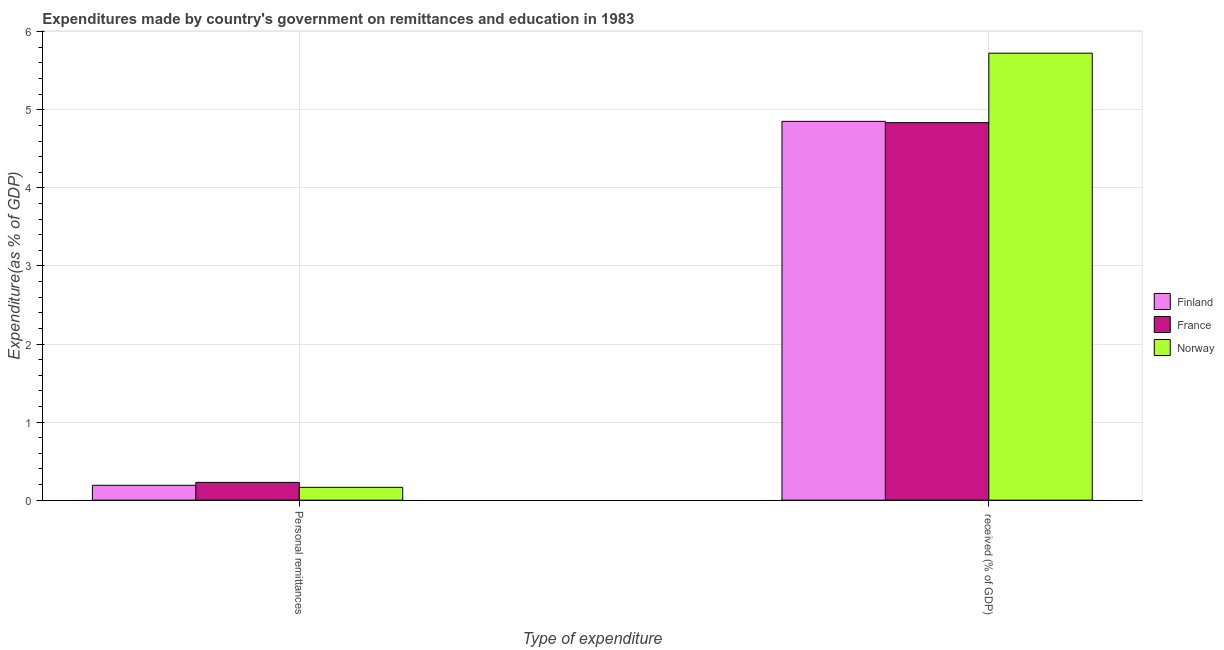How many different coloured bars are there?
Give a very brief answer. 3. Are the number of bars per tick equal to the number of legend labels?
Your response must be concise. Yes. How many bars are there on the 1st tick from the left?
Ensure brevity in your answer.  3. What is the label of the 1st group of bars from the left?
Your response must be concise. Personal remittances. What is the expenditure in personal remittances in Norway?
Your response must be concise. 0.16. Across all countries, what is the maximum expenditure in education?
Offer a terse response. 5.73. Across all countries, what is the minimum expenditure in education?
Your answer should be very brief. 4.84. In which country was the expenditure in education maximum?
Offer a very short reply. Norway. What is the total expenditure in education in the graph?
Offer a very short reply. 15.41. What is the difference between the expenditure in education in France and that in Norway?
Offer a very short reply. -0.89. What is the difference between the expenditure in education in France and the expenditure in personal remittances in Norway?
Your response must be concise. 4.67. What is the average expenditure in personal remittances per country?
Offer a terse response. 0.19. What is the difference between the expenditure in education and expenditure in personal remittances in Norway?
Provide a short and direct response. 5.56. In how many countries, is the expenditure in education greater than 5.4 %?
Offer a terse response. 1. What is the ratio of the expenditure in education in Finland to that in Norway?
Your answer should be very brief. 0.85. Is the expenditure in personal remittances in Finland less than that in Norway?
Offer a very short reply. No. In how many countries, is the expenditure in education greater than the average expenditure in education taken over all countries?
Give a very brief answer. 1. What does the 1st bar from the left in  received (% of GDP) represents?
Make the answer very short. Finland. What does the 2nd bar from the right in Personal remittances represents?
Give a very brief answer. France. Are all the bars in the graph horizontal?
Keep it short and to the point. No. What is the difference between two consecutive major ticks on the Y-axis?
Offer a very short reply. 1. Are the values on the major ticks of Y-axis written in scientific E-notation?
Ensure brevity in your answer.  No. Does the graph contain any zero values?
Offer a terse response. No. How are the legend labels stacked?
Your answer should be compact. Vertical. What is the title of the graph?
Offer a very short reply. Expenditures made by country's government on remittances and education in 1983. Does "Latvia" appear as one of the legend labels in the graph?
Offer a terse response. No. What is the label or title of the X-axis?
Give a very brief answer. Type of expenditure. What is the label or title of the Y-axis?
Provide a succinct answer. Expenditure(as % of GDP). What is the Expenditure(as % of GDP) of Finland in Personal remittances?
Make the answer very short. 0.19. What is the Expenditure(as % of GDP) of France in Personal remittances?
Provide a short and direct response. 0.23. What is the Expenditure(as % of GDP) of Norway in Personal remittances?
Make the answer very short. 0.16. What is the Expenditure(as % of GDP) of Finland in  received (% of GDP)?
Your response must be concise. 4.85. What is the Expenditure(as % of GDP) of France in  received (% of GDP)?
Ensure brevity in your answer.  4.84. What is the Expenditure(as % of GDP) of Norway in  received (% of GDP)?
Ensure brevity in your answer.  5.73. Across all Type of expenditure, what is the maximum Expenditure(as % of GDP) in Finland?
Ensure brevity in your answer.  4.85. Across all Type of expenditure, what is the maximum Expenditure(as % of GDP) of France?
Give a very brief answer. 4.84. Across all Type of expenditure, what is the maximum Expenditure(as % of GDP) of Norway?
Provide a succinct answer. 5.73. Across all Type of expenditure, what is the minimum Expenditure(as % of GDP) in Finland?
Offer a very short reply. 0.19. Across all Type of expenditure, what is the minimum Expenditure(as % of GDP) of France?
Your answer should be very brief. 0.23. Across all Type of expenditure, what is the minimum Expenditure(as % of GDP) in Norway?
Your answer should be compact. 0.16. What is the total Expenditure(as % of GDP) in Finland in the graph?
Provide a short and direct response. 5.04. What is the total Expenditure(as % of GDP) of France in the graph?
Ensure brevity in your answer.  5.06. What is the total Expenditure(as % of GDP) in Norway in the graph?
Your answer should be compact. 5.89. What is the difference between the Expenditure(as % of GDP) of Finland in Personal remittances and that in  received (% of GDP)?
Your answer should be very brief. -4.66. What is the difference between the Expenditure(as % of GDP) in France in Personal remittances and that in  received (% of GDP)?
Provide a succinct answer. -4.61. What is the difference between the Expenditure(as % of GDP) in Norway in Personal remittances and that in  received (% of GDP)?
Offer a very short reply. -5.56. What is the difference between the Expenditure(as % of GDP) in Finland in Personal remittances and the Expenditure(as % of GDP) in France in  received (% of GDP)?
Make the answer very short. -4.64. What is the difference between the Expenditure(as % of GDP) of Finland in Personal remittances and the Expenditure(as % of GDP) of Norway in  received (% of GDP)?
Offer a terse response. -5.53. What is the difference between the Expenditure(as % of GDP) of France in Personal remittances and the Expenditure(as % of GDP) of Norway in  received (% of GDP)?
Offer a terse response. -5.5. What is the average Expenditure(as % of GDP) in Finland per Type of expenditure?
Your answer should be very brief. 2.52. What is the average Expenditure(as % of GDP) in France per Type of expenditure?
Give a very brief answer. 2.53. What is the average Expenditure(as % of GDP) of Norway per Type of expenditure?
Provide a succinct answer. 2.94. What is the difference between the Expenditure(as % of GDP) of Finland and Expenditure(as % of GDP) of France in Personal remittances?
Your answer should be compact. -0.04. What is the difference between the Expenditure(as % of GDP) in Finland and Expenditure(as % of GDP) in Norway in Personal remittances?
Give a very brief answer. 0.03. What is the difference between the Expenditure(as % of GDP) in France and Expenditure(as % of GDP) in Norway in Personal remittances?
Provide a succinct answer. 0.06. What is the difference between the Expenditure(as % of GDP) in Finland and Expenditure(as % of GDP) in France in  received (% of GDP)?
Ensure brevity in your answer.  0.02. What is the difference between the Expenditure(as % of GDP) in Finland and Expenditure(as % of GDP) in Norway in  received (% of GDP)?
Provide a succinct answer. -0.87. What is the difference between the Expenditure(as % of GDP) of France and Expenditure(as % of GDP) of Norway in  received (% of GDP)?
Your answer should be very brief. -0.89. What is the ratio of the Expenditure(as % of GDP) of Finland in Personal remittances to that in  received (% of GDP)?
Provide a short and direct response. 0.04. What is the ratio of the Expenditure(as % of GDP) of France in Personal remittances to that in  received (% of GDP)?
Your answer should be very brief. 0.05. What is the ratio of the Expenditure(as % of GDP) in Norway in Personal remittances to that in  received (% of GDP)?
Provide a short and direct response. 0.03. What is the difference between the highest and the second highest Expenditure(as % of GDP) in Finland?
Give a very brief answer. 4.66. What is the difference between the highest and the second highest Expenditure(as % of GDP) in France?
Keep it short and to the point. 4.61. What is the difference between the highest and the second highest Expenditure(as % of GDP) of Norway?
Offer a terse response. 5.56. What is the difference between the highest and the lowest Expenditure(as % of GDP) in Finland?
Your answer should be very brief. 4.66. What is the difference between the highest and the lowest Expenditure(as % of GDP) of France?
Provide a succinct answer. 4.61. What is the difference between the highest and the lowest Expenditure(as % of GDP) of Norway?
Your answer should be very brief. 5.56. 